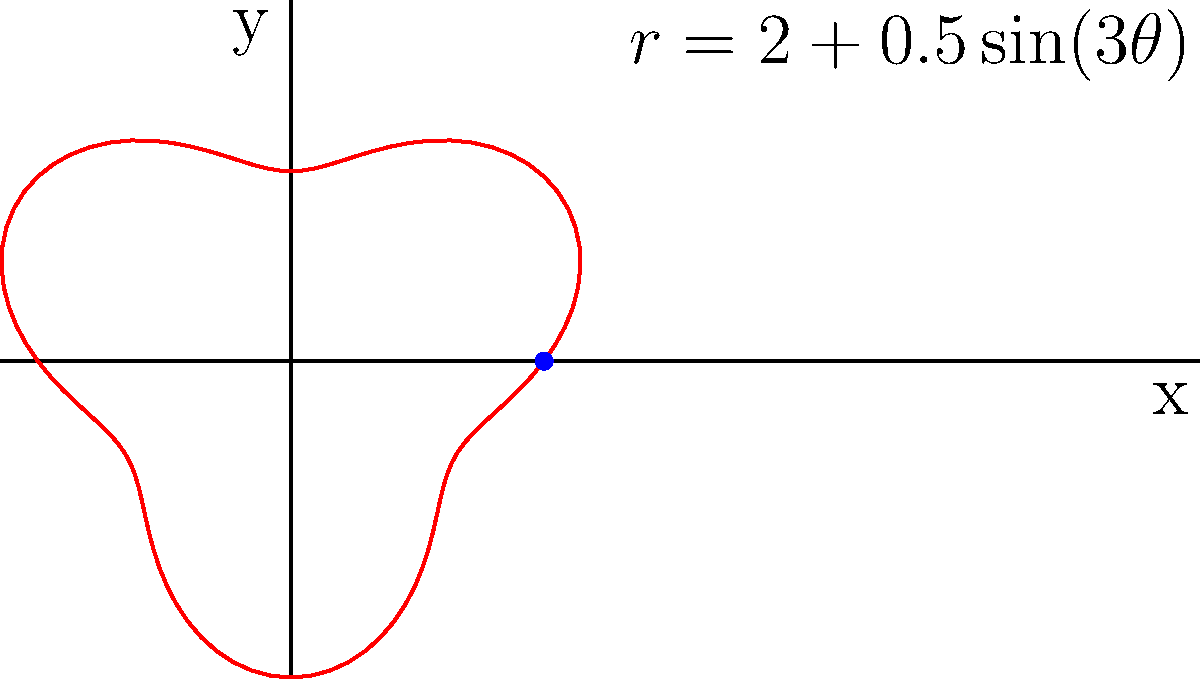As a calligrapher, you're inscribing a name on a curved surface of a pottery piece. The curve of the inscription follows the polar equation $r = 2 + 0.5\sin(3\theta)$, where $r$ is in inches. Calculate the total length of the inscription using a line integral in polar coordinates. To find the length of the curve, we'll use the line integral formula for arc length in polar coordinates:

1) The formula is: $L = \int_{0}^{2\pi} \sqrt{r^2 + \left(\frac{dr}{d\theta}\right)^2} d\theta$

2) We have $r = 2 + 0.5\sin(3\theta)$

3) Calculate $\frac{dr}{d\theta}$:
   $\frac{dr}{d\theta} = 0.5 \cdot 3 \cos(3\theta) = 1.5\cos(3\theta)$

4) Substitute into the formula:
   $L = \int_{0}^{2\pi} \sqrt{(2 + 0.5\sin(3\theta))^2 + (1.5\cos(3\theta))^2} d\theta$

5) Simplify under the square root:
   $L = \int_{0}^{2\pi} \sqrt{4 + 2\sin(3\theta) + 0.25\sin^2(3\theta) + 2.25\cos^2(3\theta)} d\theta$

6) This integral cannot be solved analytically. We need to use numerical integration methods to approximate the result.

7) Using a numerical integration method (like Simpson's rule or trapezoidal rule), we get:
   $L \approx 13.3649$ inches

Therefore, the total length of the inscription is approximately 13.3649 inches.
Answer: $13.3649$ inches 